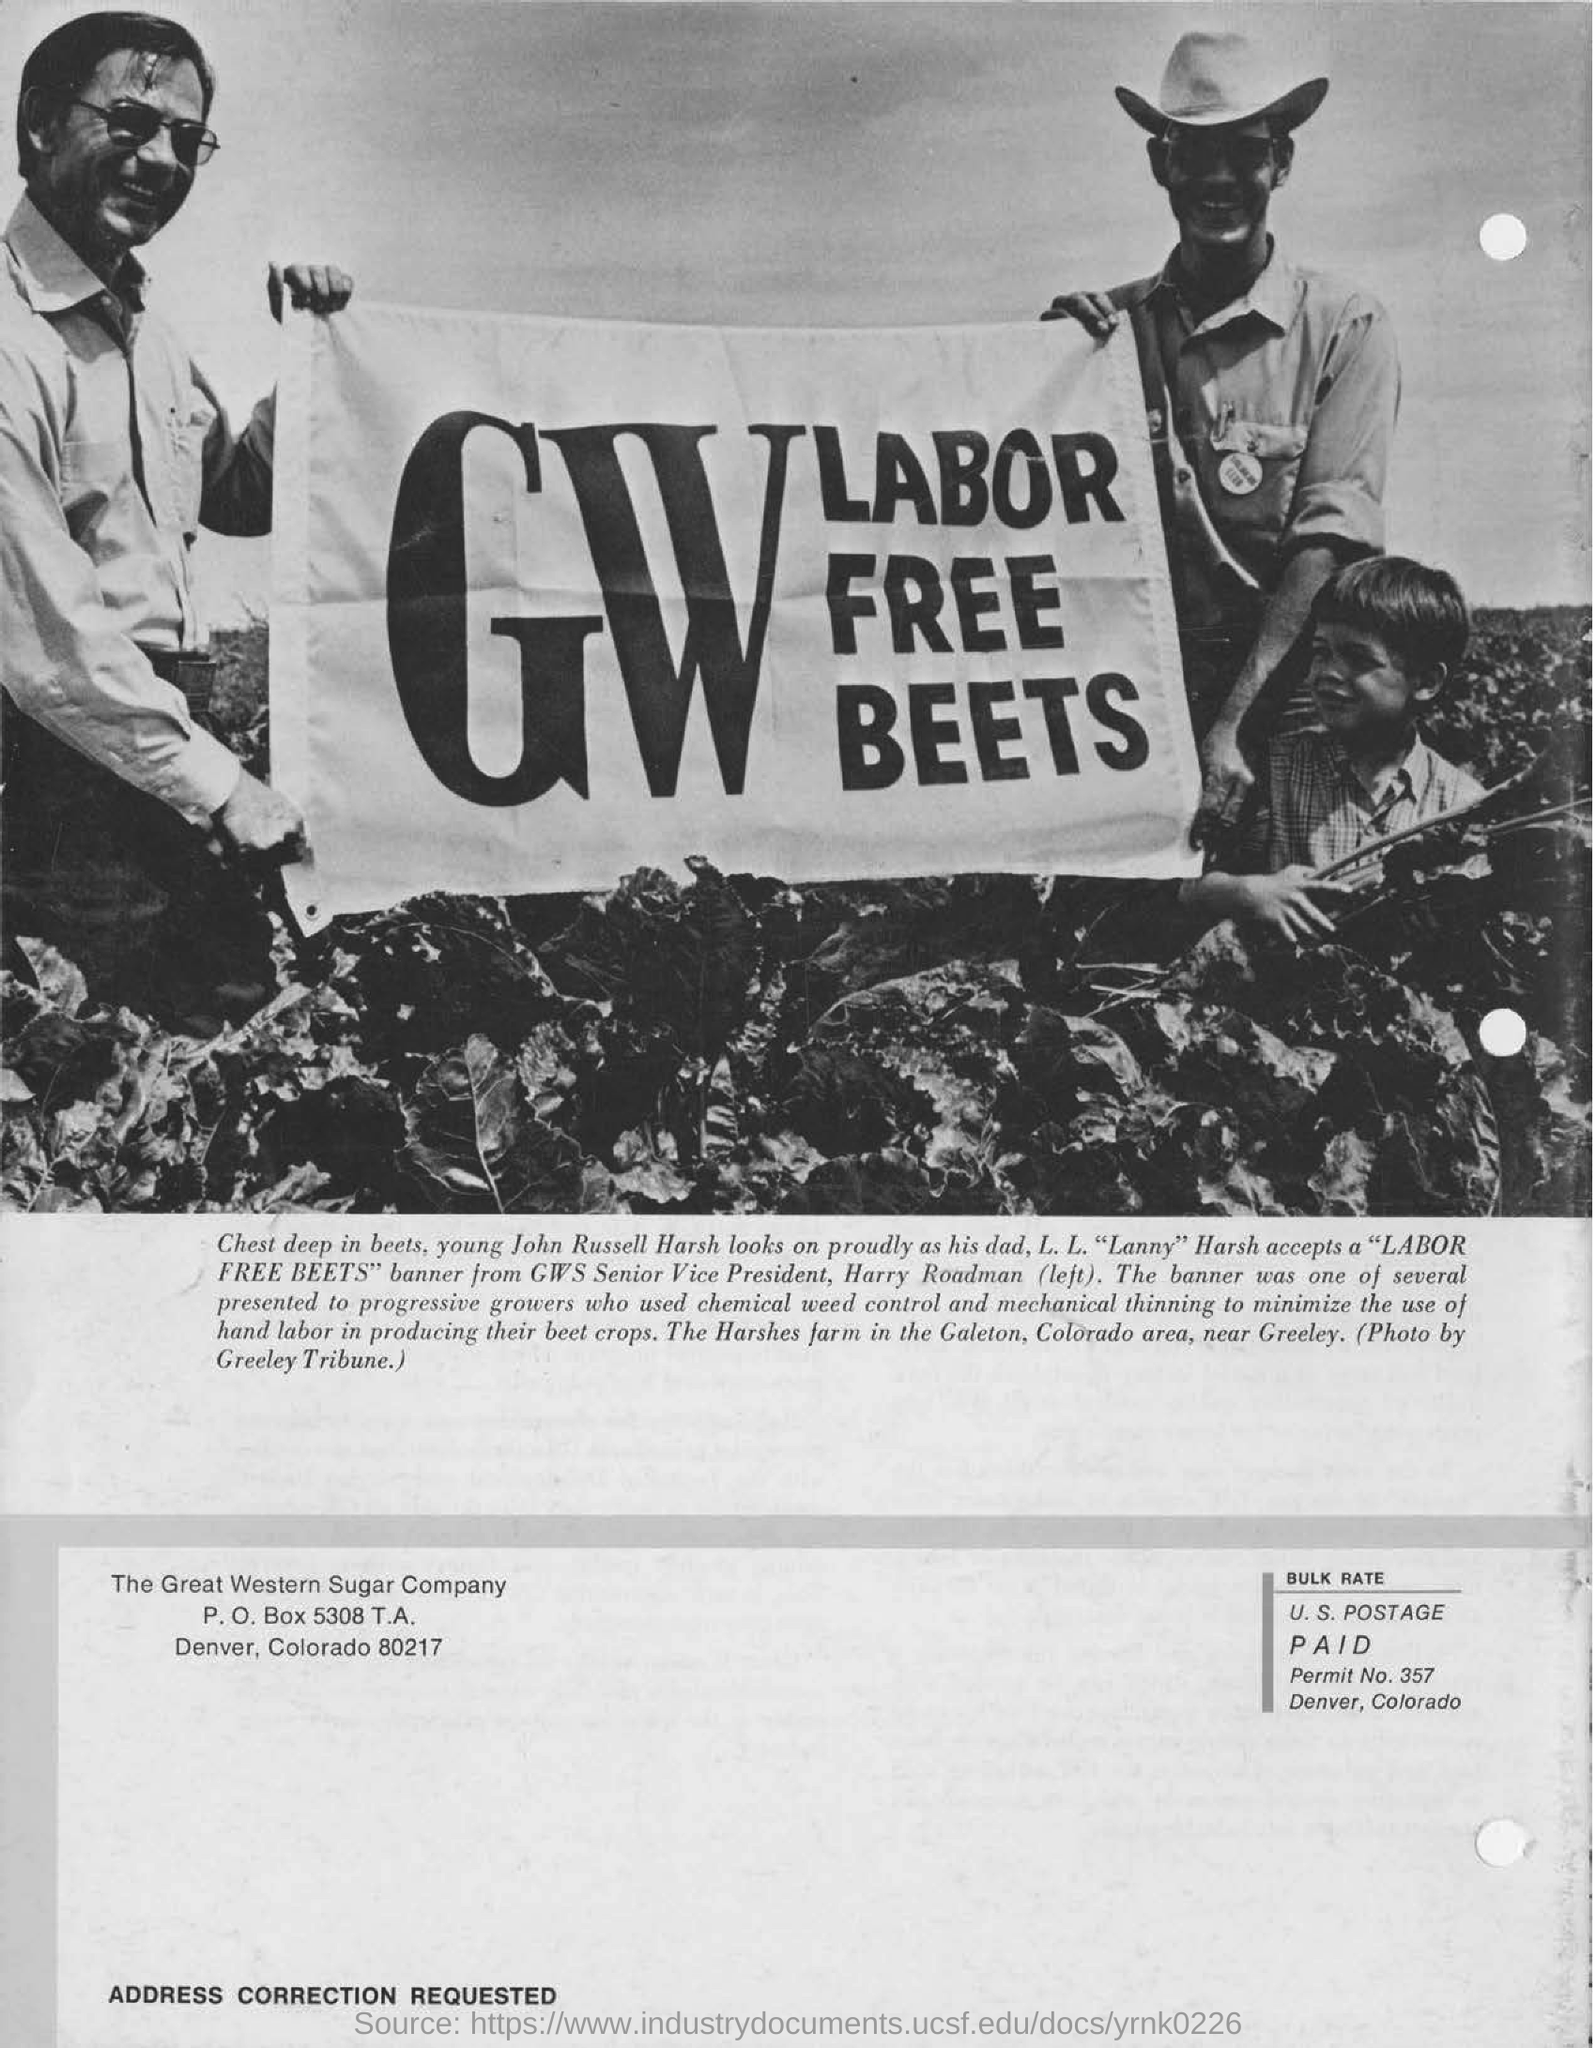Point out several critical features in this image. The two people in the picture are holding up a sign that reads "GW Labor Free Beets. The photograph is by the Greeley Tribune. Harry Roadman is the Senior Vice President of GWS. 